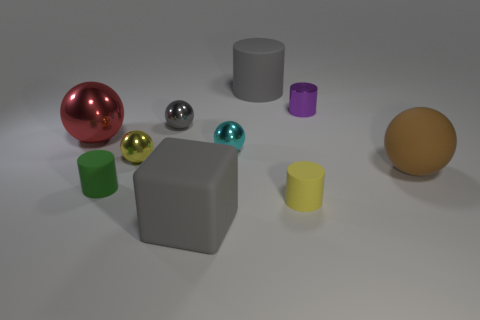There is a small cyan metal object; is its shape the same as the large gray thing in front of the big brown thing?
Your answer should be compact. No. How many matte objects are small green objects or tiny gray cubes?
Your answer should be compact. 1. Are there any matte cylinders that have the same color as the big block?
Provide a succinct answer. Yes. Is there a purple cylinder?
Provide a short and direct response. Yes. Does the small cyan metal object have the same shape as the yellow matte object?
Keep it short and to the point. No. What number of small objects are either gray matte cubes or green rubber things?
Your response must be concise. 1. The rubber sphere is what color?
Provide a succinct answer. Brown. There is a big gray rubber object in front of the tiny metallic sphere in front of the cyan shiny sphere; what is its shape?
Provide a succinct answer. Cube. Are there any cyan objects that have the same material as the green cylinder?
Offer a terse response. No. There is a cylinder on the left side of the cyan ball; is it the same size as the large red thing?
Make the answer very short. No. 